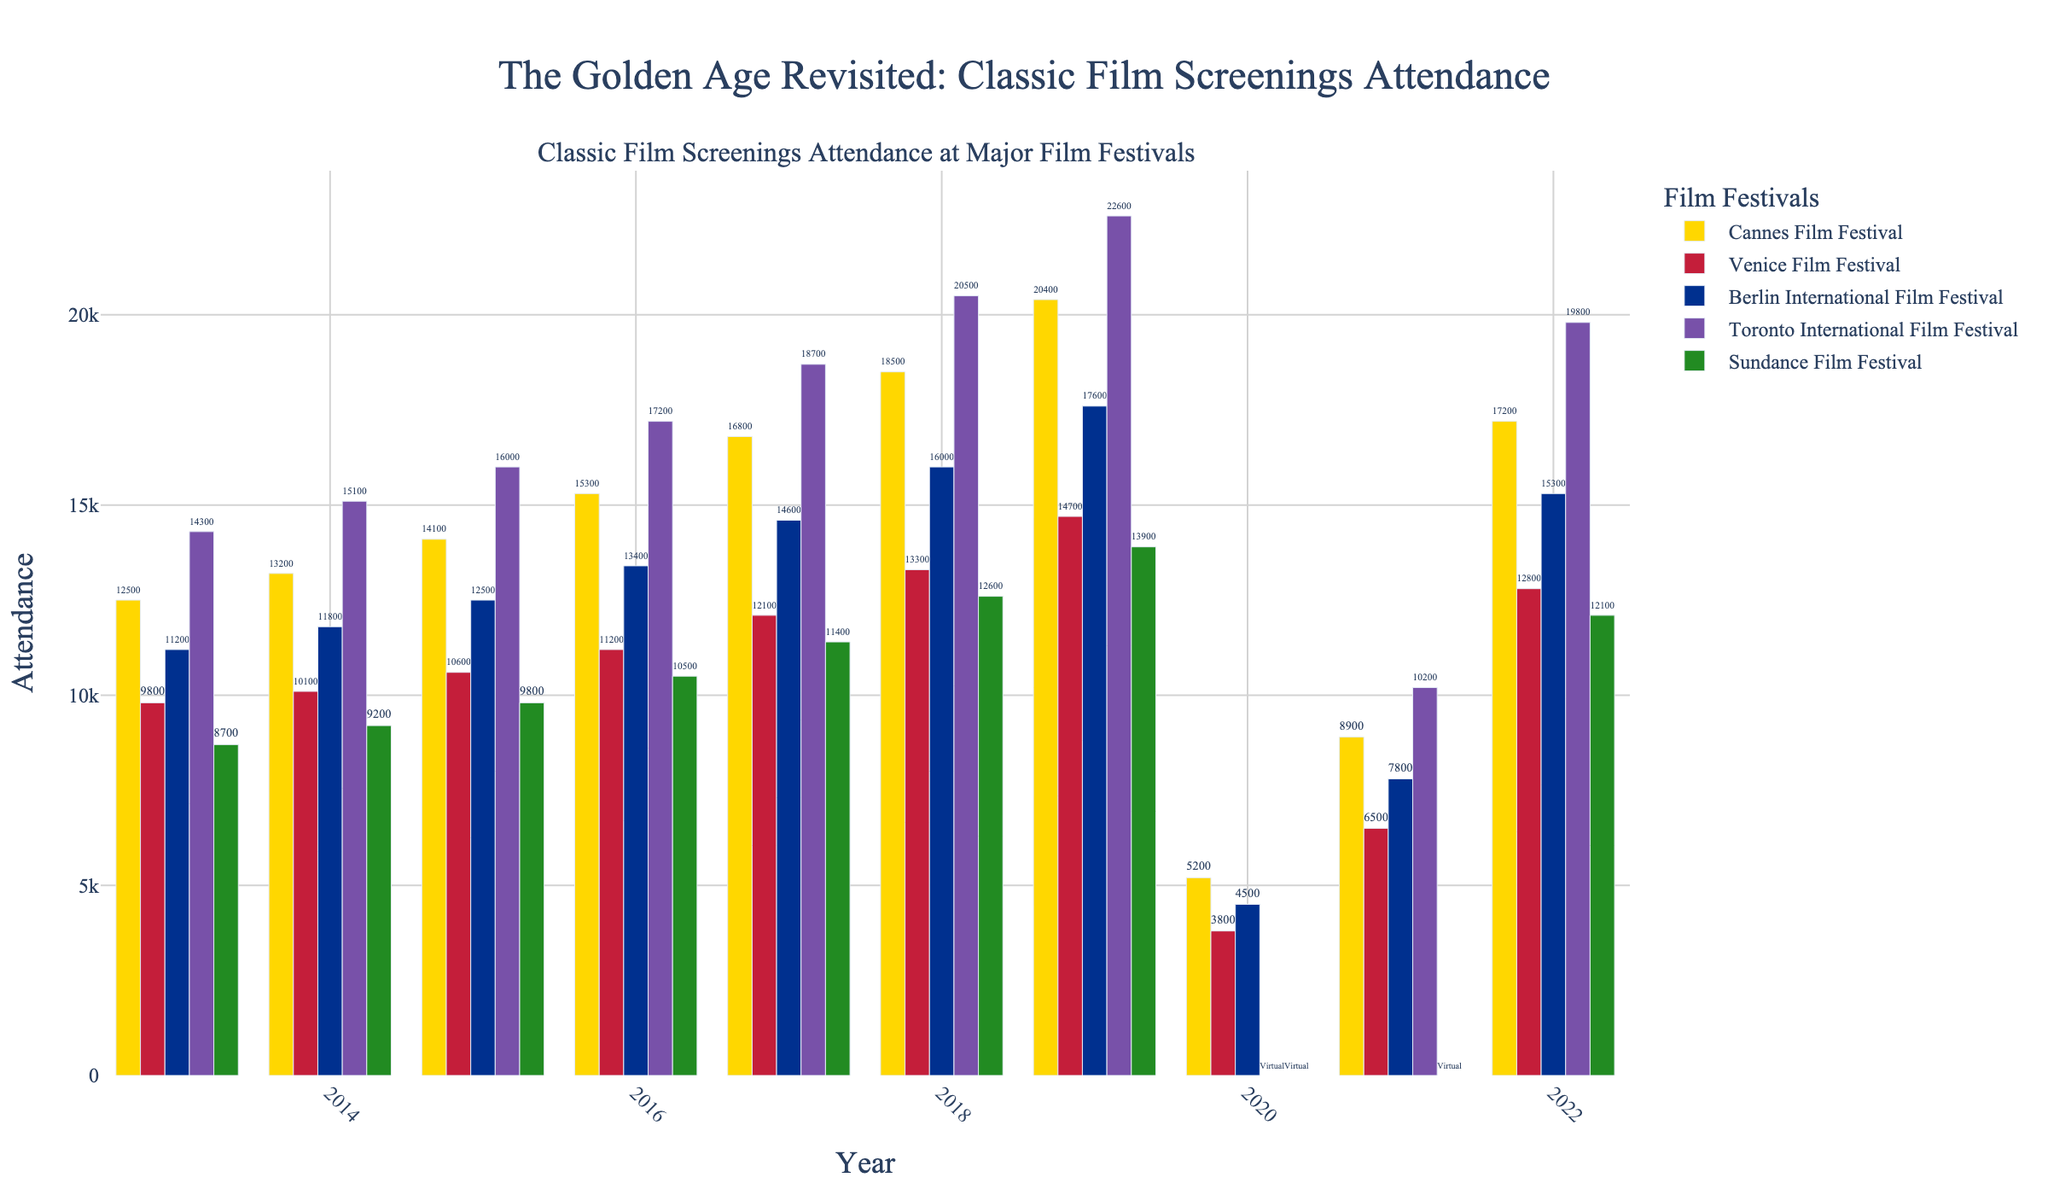Which film festival had the highest attendance in 2019? To determine the highest attendance in 2019, compare the attendance figures for all festivals in that year. Cannes had 20400, Venice had 14700, Berlin had 17600, Toronto had 22600, and Sundance had 13900. Toronto had the highest attendance.
Answer: Toronto International Film Festival How did the attendance at the Cannes Film Festival change from 2013 to 2019? Calculate the difference in attendance between 2019 and 2013 for the Cannes Film Festival. The 2013 figure is 12500, and the 2019 figure is 20400. Subtract 12500 from 20400.
Answer: Increased by 7900 Which festivals were held virtually in 2020 and 2021? Look at the data entries for 2020 and 2021. The Toronto International Film Festival and Sundance Film Festival are labeled "Virtual". For 2021, only Sundance is labeled "Virtual".
Answer: Toronto and Sundance What is the average attendance at the Berlin International Film Festival from 2013 to 2019? Sum the attendance figures for Berlin from 2013 to 2019, then divide by the number of years (7). (11200 + 11800 + 12500 + 13400 + 14600 + 16000 + 17600) / 7 = 97100 / 7 = 13871.43
Answer: 13871.43 What was the percentage increase in attendance for the Venice Film Festival from 2013 to 2018? Calculate the percentage increase from 2013 to 2018. The attendance in 2013 was 9800, and in 2018 it was 13300. Use the formula ((New-Old)/Old) * 100. ((13300-9800)/9800) * 100 = 35.71%
Answer: 35.71% Which festival had the most significant year-to-year increase in attendance from 2017 to 2018? Check the attendance figures from 2017 to 2018 for all festivals. The increases are as follows: Cannes (16800 to 18500), Venice (12100 to 13300), Berlin (14600 to 16000), Toronto (18700 to 20500), Sundance (11400 to 12600). Calculate each increase: Cannes (1700), Venice (1200), Berlin (1400), Toronto (1800), Sundance (1200). Toronto had the most significant increase of 1800.
Answer: Toronto International Film Festival Which festival had the lowest attendance in 2021? Compare the attendance figures for 2021 for all festivals. Cannes had 8900, Venice had 6500, Berlin had 7800, Toronto had 10200, and Sundance was Virtual. Venice had the lowest attendance.
Answer: Venice Film Festival Which festival showed the most recovery from 2020 to 2022? Compare the figure decreases in 2020 due to virtual events and the recovery figures by 2022. Calculate the difference between 2020 attendance to 2022 (Cannes: 5200 to 17200, Venice: 3800 to 12800, Berlin: 4500 to 15300, Toronto: Virtual to 19800, Sundance: Virtual to 12100). Cannes showed the recovery from 5200 to 17200 = 12000.
Answer: Cannes Film Festival 